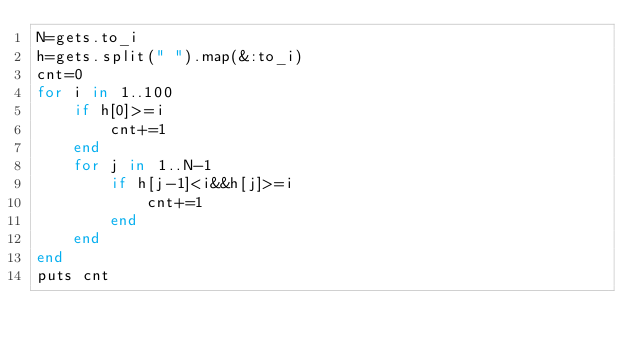<code> <loc_0><loc_0><loc_500><loc_500><_Ruby_>N=gets.to_i
h=gets.split(" ").map(&:to_i)
cnt=0
for i in 1..100
	if h[0]>=i
		cnt+=1
	end
	for j in 1..N-1
		if h[j-1]<i&&h[j]>=i
			cnt+=1
		end
	end
end
puts cnt</code> 